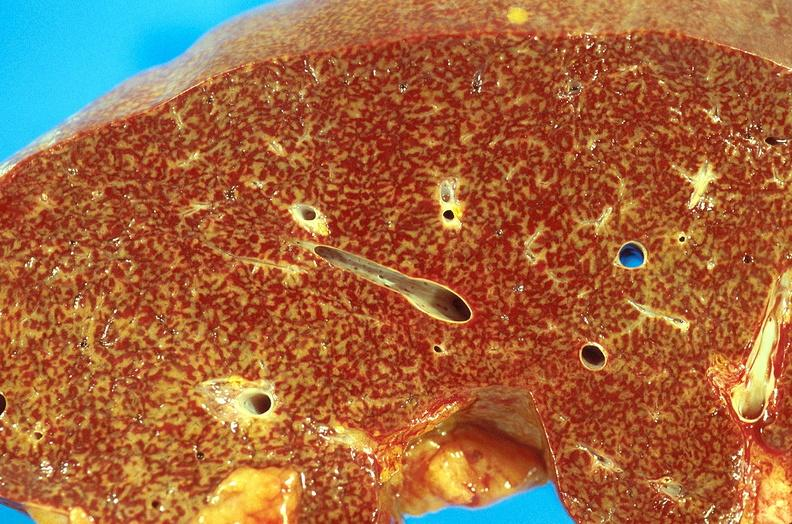s the tumor present?
Answer the question using a single word or phrase. No 